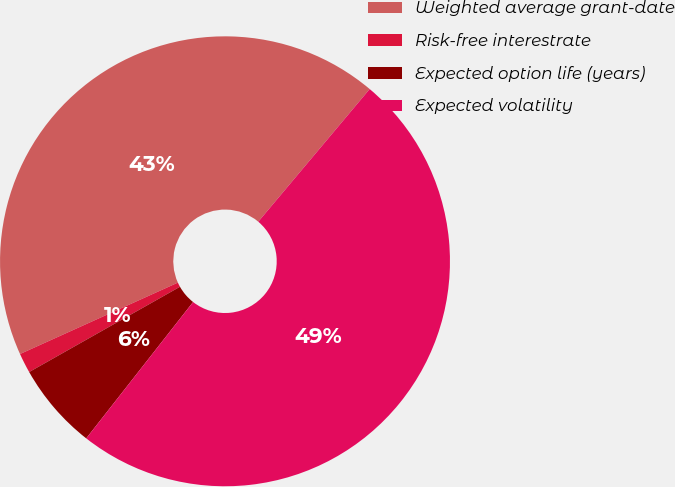Convert chart to OTSL. <chart><loc_0><loc_0><loc_500><loc_500><pie_chart><fcel>Weighted average grant-date<fcel>Risk-free interestrate<fcel>Expected option life (years)<fcel>Expected volatility<nl><fcel>42.88%<fcel>1.43%<fcel>6.23%<fcel>49.46%<nl></chart> 